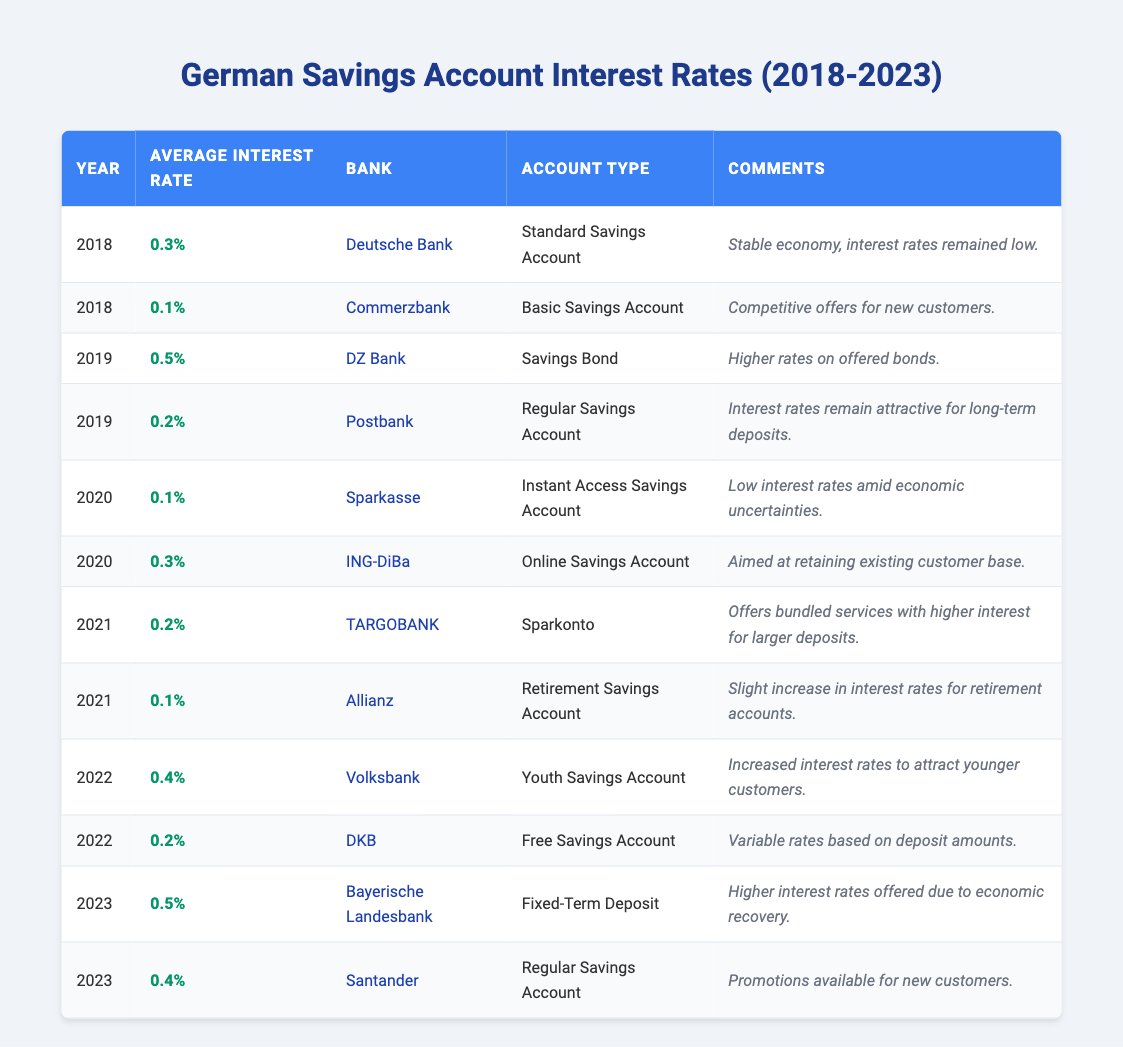What was the average interest rate for Deutsche Bank's Standard Savings Account in 2018? The table indicates the average interest rate for Deutsche Bank's Standard Savings Account in 2018 was 0.3%.
Answer: 0.3% Which bank offered the highest average interest rate in 2019? In 2019, DZ Bank offered the highest average interest rate of 0.5% on Savings Bonds.
Answer: DZ Bank What is the percentage increase in the average interest rate for Bayerische Landesbank's Fixed-Term Deposit from 2022 to 2023? The average interest rate for Bayerische Landesbank's Fixed-Term Deposit was 0.0% in 2022 and rose to 0.5% in 2023. Therefore, the increase is 0.5% - 0.0% = 0.5%.
Answer: 0.5% Did Allianz offer a higher interest rate in 2021 than TARGOBANK? Allianz offered an average interest rate of 0.1% for Retirement Savings Accounts in 2021, while TARGOBANK offered 0.2% for Sparkonto, which is higher. Thus, the statement is false.
Answer: No What was the average interest rate for online savings accounts in 2020 compared to 2021? In 2020, ING-DiBa offered an average interest rate of 0.3% for Online Savings Accounts. In 2021, TARGOBANK offered 0.2% for Sparkonto, which is lower. So, the average interest rate for online savings accounts decreased from 2020 to 2021.
Answer: Decreased Which year saw an increase in interest rates for youth savings accounts, and what was the average rate provided by Volksbank in that year? The year 2022 saw an increase in interest rates for youth savings accounts, with Volksbank offering an average rate of 0.4%.
Answer: 2022, 0.4% How many banks offered savings accounts with an average interest rate of 0.1% in 2018 and 2020? In 2018, Commerzbank offered 0.1% for Basic Savings Accounts, and in 2020, Sparkasse offered 0.1% for Instant Access Savings Accounts. Therefore, there were two banks offering this rate across those years.
Answer: 2 What was the variable nature of interest rates for DKB’s Free Savings Account in 2022? The table notes that DKB's Free Savings Account had variable rates based on deposit amounts, indicating that the interest rate could change depending on how much was deposited.
Answer: Variable rates based on deposit amounts 